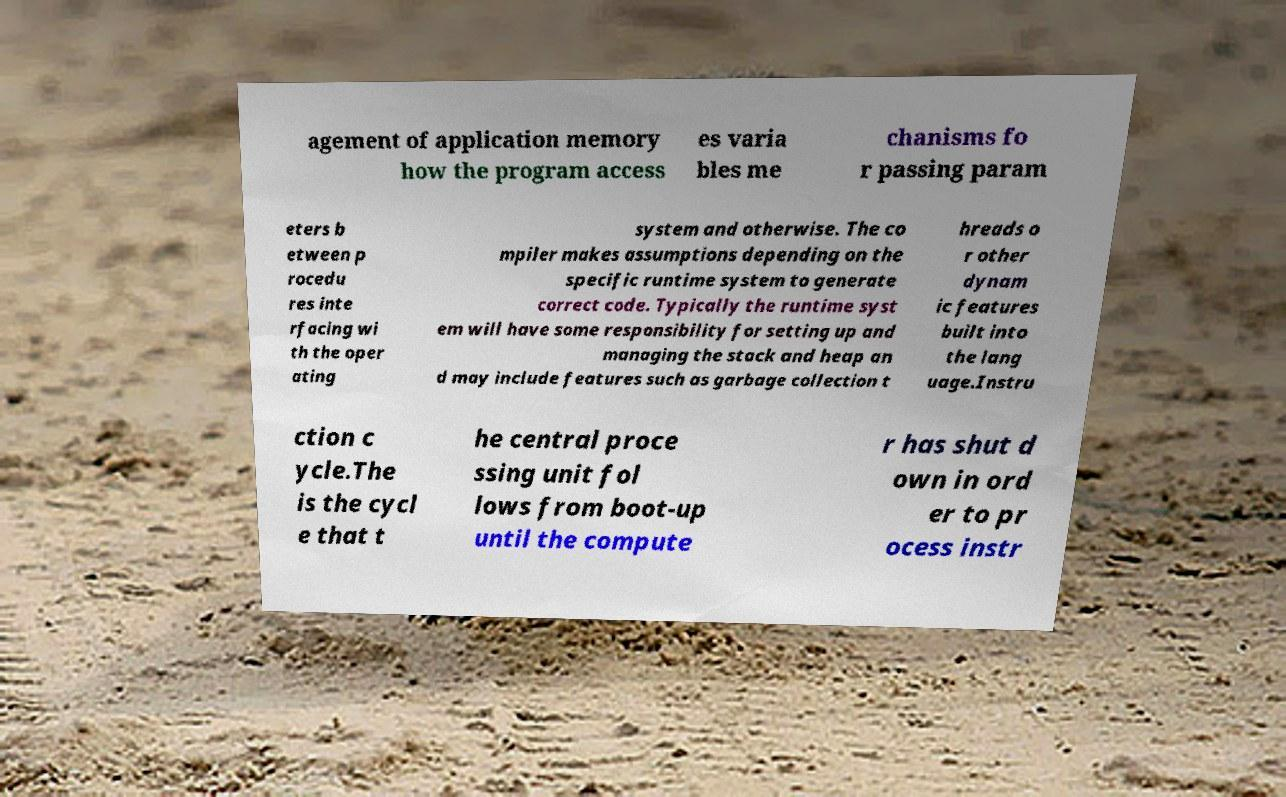Please identify and transcribe the text found in this image. agement of application memory how the program access es varia bles me chanisms fo r passing param eters b etween p rocedu res inte rfacing wi th the oper ating system and otherwise. The co mpiler makes assumptions depending on the specific runtime system to generate correct code. Typically the runtime syst em will have some responsibility for setting up and managing the stack and heap an d may include features such as garbage collection t hreads o r other dynam ic features built into the lang uage.Instru ction c ycle.The is the cycl e that t he central proce ssing unit fol lows from boot-up until the compute r has shut d own in ord er to pr ocess instr 